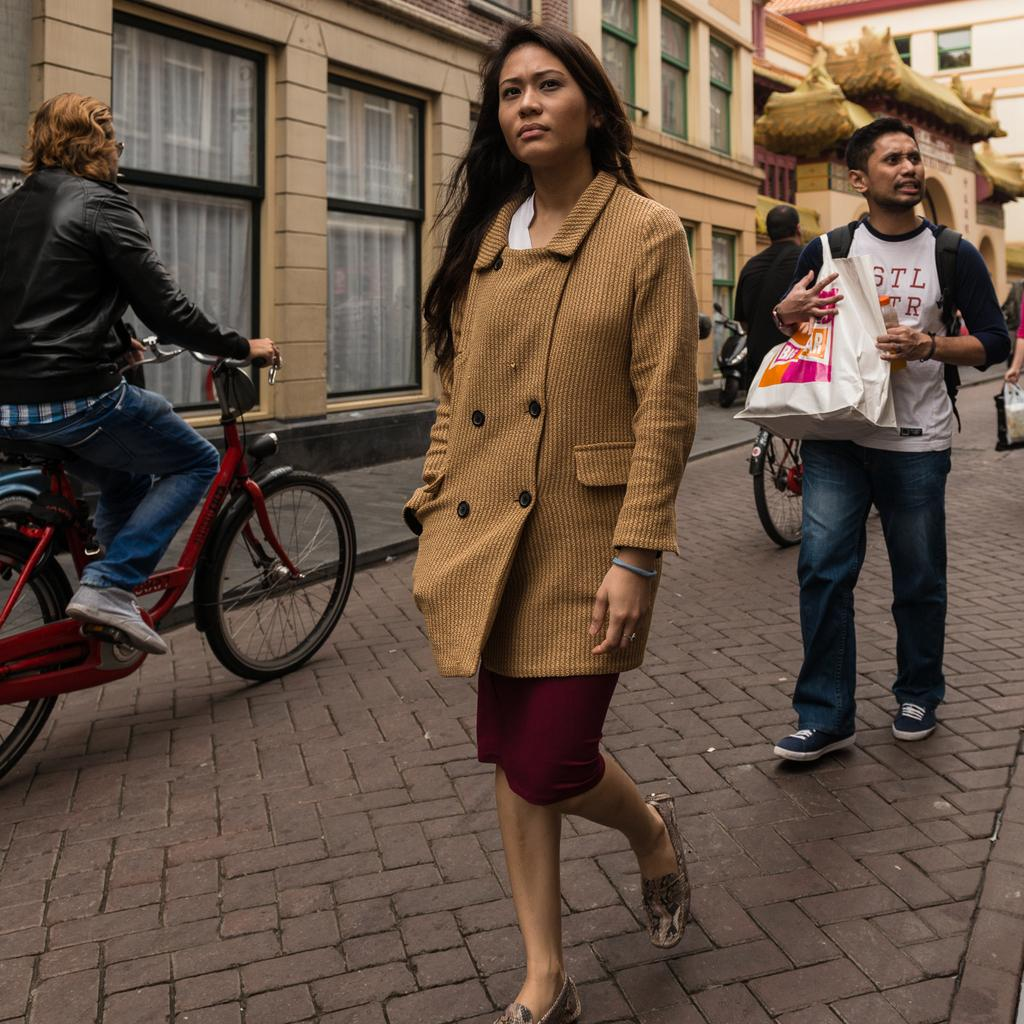Who can be seen in the image? There is a woman and a man in the image. What are the woman and the man doing in the image? Both the woman and the man are walking on the road. Are there any other people in the image besides the woman and the man? Yes, there are two persons on a bicycle in the image. What can be seen in the background of the image? There is a building in the image. What type of star can be seen in the image? There is no star visible in the image; it features a woman, a man, two persons on a bicycle, and a building. How many cakes are being carried by the woman in the image? There is no mention of cakes in the image; the woman and the man are walking on the road, and there are two persons on a bicycle. 